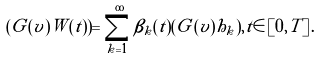Convert formula to latex. <formula><loc_0><loc_0><loc_500><loc_500>( G ( v ) W ( t ) ) = \sum _ { k = 1 } ^ { \infty } \beta _ { k } ( t ) ( G ( v ) h _ { k } ) , t \in \left [ 0 , T \right ] .</formula> 